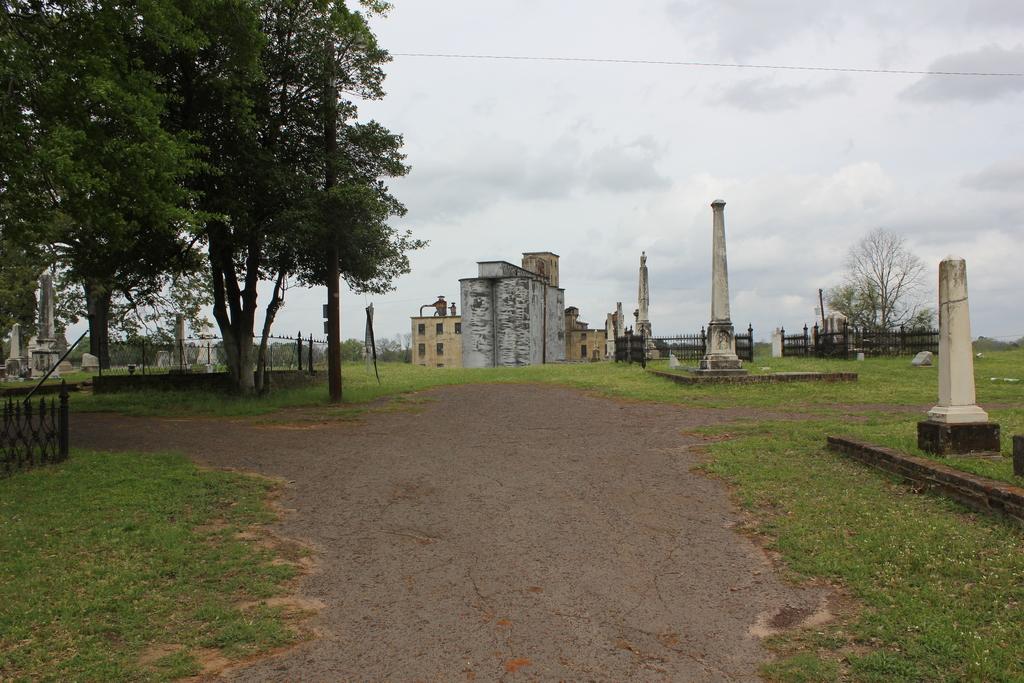Can you describe this image briefly? In this image we can see the buildings. And there are pillars, fence, ground, trees and the sky. 